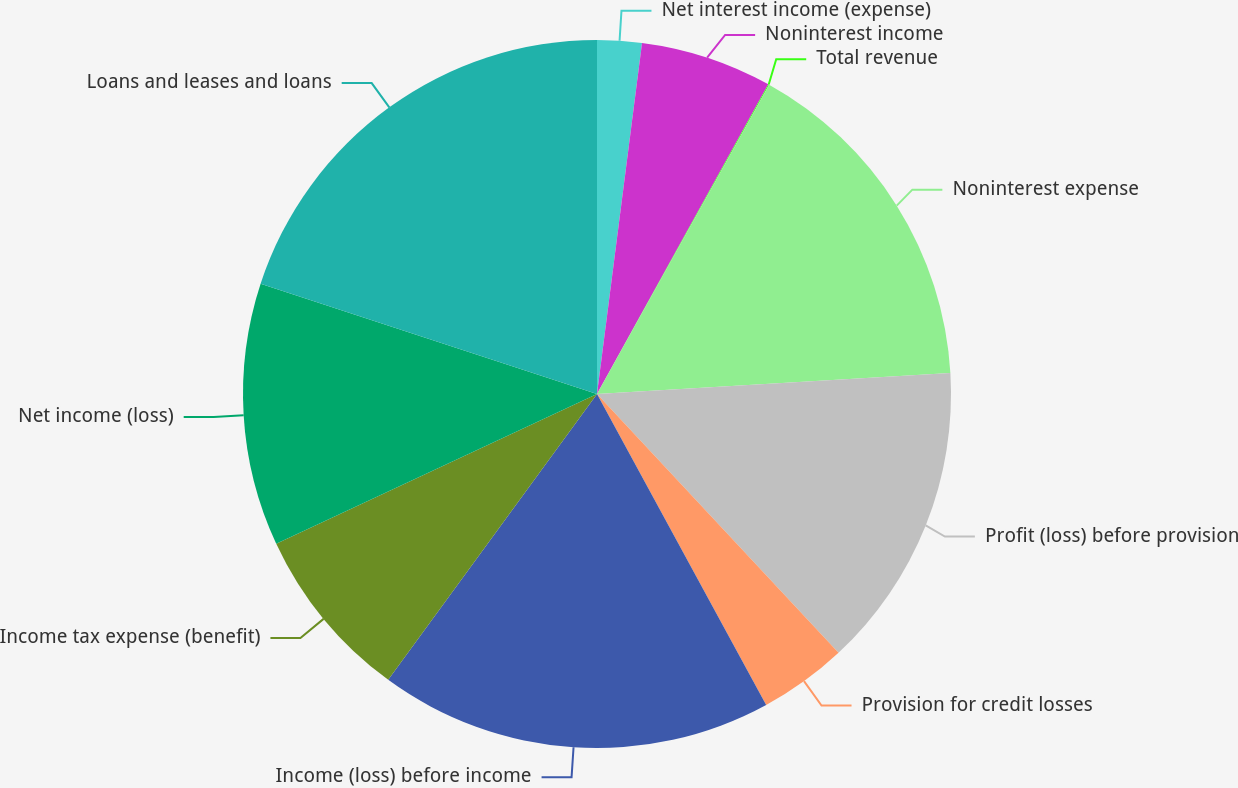Convert chart to OTSL. <chart><loc_0><loc_0><loc_500><loc_500><pie_chart><fcel>Net interest income (expense)<fcel>Noninterest income<fcel>Total revenue<fcel>Noninterest expense<fcel>Profit (loss) before provision<fcel>Provision for credit losses<fcel>Income (loss) before income<fcel>Income tax expense (benefit)<fcel>Net income (loss)<fcel>Loans and leases and loans<nl><fcel>2.03%<fcel>6.01%<fcel>0.04%<fcel>15.98%<fcel>13.99%<fcel>4.02%<fcel>17.97%<fcel>8.01%<fcel>11.99%<fcel>19.96%<nl></chart> 